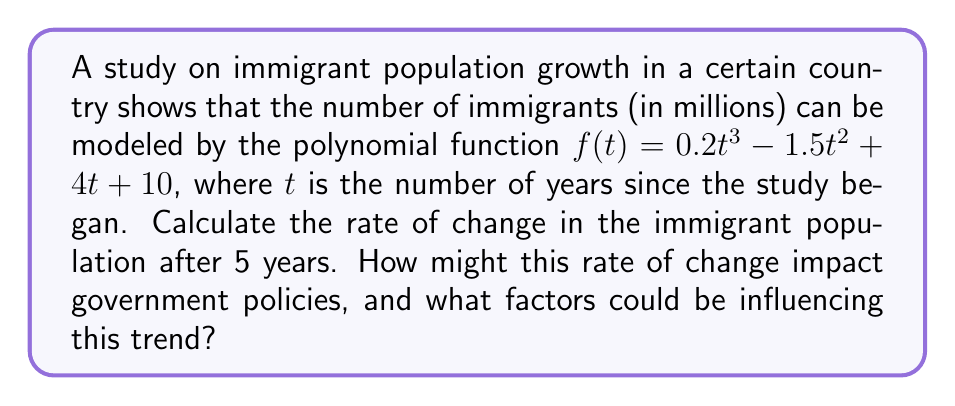Can you solve this math problem? To find the rate of change in the immigrant population after 5 years, we need to calculate the derivative of the given function and evaluate it at $t=5$. Here's the step-by-step process:

1. Given function: $f(t) = 0.2t^3 - 1.5t^2 + 4t + 10$

2. Calculate the derivative $f'(t)$:
   $f'(t) = 0.6t^2 - 3t + 4$

3. Evaluate $f'(5)$:
   $f'(5) = 0.6(5^2) - 3(5) + 4$
   $f'(5) = 0.6(25) - 15 + 4$
   $f'(5) = 15 - 15 + 4$
   $f'(5) = 4$

The rate of change after 5 years is 4 million immigrants per year. This positive rate indicates a growing immigrant population, which could influence government policies in areas such as housing, education, and social services. Factors influencing this trend might include economic opportunities, political stability, or humanitarian crises in other regions.
Answer: 4 million immigrants per year 